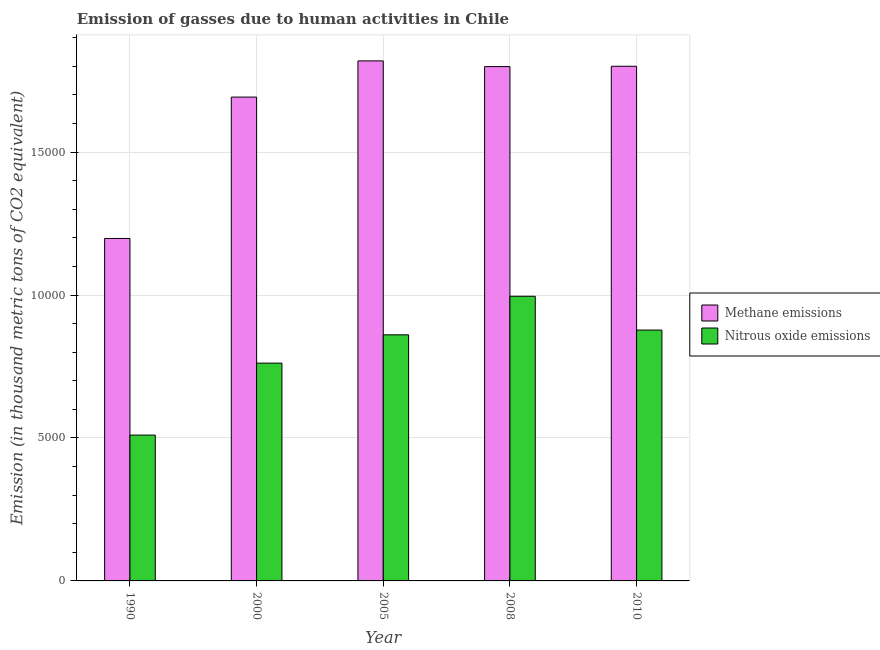How many different coloured bars are there?
Provide a short and direct response. 2. How many bars are there on the 1st tick from the right?
Your answer should be compact. 2. What is the label of the 4th group of bars from the left?
Provide a succinct answer. 2008. In how many cases, is the number of bars for a given year not equal to the number of legend labels?
Ensure brevity in your answer.  0. What is the amount of nitrous oxide emissions in 2000?
Offer a terse response. 7617.9. Across all years, what is the maximum amount of methane emissions?
Offer a terse response. 1.82e+04. Across all years, what is the minimum amount of nitrous oxide emissions?
Your answer should be very brief. 5100.7. In which year was the amount of nitrous oxide emissions maximum?
Give a very brief answer. 2008. In which year was the amount of methane emissions minimum?
Give a very brief answer. 1990. What is the total amount of nitrous oxide emissions in the graph?
Ensure brevity in your answer.  4.01e+04. What is the difference between the amount of methane emissions in 1990 and that in 2010?
Your answer should be very brief. -6023.2. What is the difference between the amount of methane emissions in 1990 and the amount of nitrous oxide emissions in 2000?
Provide a succinct answer. -4945.1. What is the average amount of nitrous oxide emissions per year?
Your response must be concise. 8011.34. In the year 2000, what is the difference between the amount of methane emissions and amount of nitrous oxide emissions?
Provide a short and direct response. 0. In how many years, is the amount of methane emissions greater than 14000 thousand metric tons?
Your answer should be very brief. 4. What is the ratio of the amount of methane emissions in 2005 to that in 2010?
Make the answer very short. 1.01. Is the amount of methane emissions in 2008 less than that in 2010?
Ensure brevity in your answer.  Yes. Is the difference between the amount of methane emissions in 1990 and 2010 greater than the difference between the amount of nitrous oxide emissions in 1990 and 2010?
Give a very brief answer. No. What is the difference between the highest and the second highest amount of methane emissions?
Keep it short and to the point. 188.4. What is the difference between the highest and the lowest amount of methane emissions?
Offer a terse response. 6211.6. Is the sum of the amount of methane emissions in 1990 and 2000 greater than the maximum amount of nitrous oxide emissions across all years?
Ensure brevity in your answer.  Yes. What does the 2nd bar from the left in 1990 represents?
Your answer should be compact. Nitrous oxide emissions. What does the 1st bar from the right in 2000 represents?
Make the answer very short. Nitrous oxide emissions. How many bars are there?
Give a very brief answer. 10. Are all the bars in the graph horizontal?
Your answer should be very brief. No. Are the values on the major ticks of Y-axis written in scientific E-notation?
Ensure brevity in your answer.  No. Does the graph contain grids?
Your response must be concise. Yes. Where does the legend appear in the graph?
Provide a short and direct response. Center right. How many legend labels are there?
Your response must be concise. 2. What is the title of the graph?
Provide a succinct answer. Emission of gasses due to human activities in Chile. Does "Arms exports" appear as one of the legend labels in the graph?
Give a very brief answer. No. What is the label or title of the X-axis?
Your response must be concise. Year. What is the label or title of the Y-axis?
Offer a very short reply. Emission (in thousand metric tons of CO2 equivalent). What is the Emission (in thousand metric tons of CO2 equivalent) in Methane emissions in 1990?
Give a very brief answer. 1.20e+04. What is the Emission (in thousand metric tons of CO2 equivalent) in Nitrous oxide emissions in 1990?
Provide a succinct answer. 5100.7. What is the Emission (in thousand metric tons of CO2 equivalent) in Methane emissions in 2000?
Your answer should be compact. 1.69e+04. What is the Emission (in thousand metric tons of CO2 equivalent) of Nitrous oxide emissions in 2000?
Offer a terse response. 7617.9. What is the Emission (in thousand metric tons of CO2 equivalent) in Methane emissions in 2005?
Provide a short and direct response. 1.82e+04. What is the Emission (in thousand metric tons of CO2 equivalent) in Nitrous oxide emissions in 2005?
Your answer should be very brief. 8607.6. What is the Emission (in thousand metric tons of CO2 equivalent) in Methane emissions in 2008?
Give a very brief answer. 1.80e+04. What is the Emission (in thousand metric tons of CO2 equivalent) in Nitrous oxide emissions in 2008?
Your answer should be compact. 9956.7. What is the Emission (in thousand metric tons of CO2 equivalent) in Methane emissions in 2010?
Provide a succinct answer. 1.80e+04. What is the Emission (in thousand metric tons of CO2 equivalent) in Nitrous oxide emissions in 2010?
Offer a very short reply. 8773.8. Across all years, what is the maximum Emission (in thousand metric tons of CO2 equivalent) of Methane emissions?
Your response must be concise. 1.82e+04. Across all years, what is the maximum Emission (in thousand metric tons of CO2 equivalent) in Nitrous oxide emissions?
Give a very brief answer. 9956.7. Across all years, what is the minimum Emission (in thousand metric tons of CO2 equivalent) in Methane emissions?
Your answer should be very brief. 1.20e+04. Across all years, what is the minimum Emission (in thousand metric tons of CO2 equivalent) in Nitrous oxide emissions?
Your response must be concise. 5100.7. What is the total Emission (in thousand metric tons of CO2 equivalent) of Methane emissions in the graph?
Give a very brief answer. 8.31e+04. What is the total Emission (in thousand metric tons of CO2 equivalent) of Nitrous oxide emissions in the graph?
Offer a very short reply. 4.01e+04. What is the difference between the Emission (in thousand metric tons of CO2 equivalent) of Methane emissions in 1990 and that in 2000?
Your answer should be very brief. -4945.1. What is the difference between the Emission (in thousand metric tons of CO2 equivalent) in Nitrous oxide emissions in 1990 and that in 2000?
Keep it short and to the point. -2517.2. What is the difference between the Emission (in thousand metric tons of CO2 equivalent) in Methane emissions in 1990 and that in 2005?
Keep it short and to the point. -6211.6. What is the difference between the Emission (in thousand metric tons of CO2 equivalent) in Nitrous oxide emissions in 1990 and that in 2005?
Provide a short and direct response. -3506.9. What is the difference between the Emission (in thousand metric tons of CO2 equivalent) of Methane emissions in 1990 and that in 2008?
Your response must be concise. -6011.3. What is the difference between the Emission (in thousand metric tons of CO2 equivalent) of Nitrous oxide emissions in 1990 and that in 2008?
Offer a very short reply. -4856. What is the difference between the Emission (in thousand metric tons of CO2 equivalent) of Methane emissions in 1990 and that in 2010?
Keep it short and to the point. -6023.2. What is the difference between the Emission (in thousand metric tons of CO2 equivalent) in Nitrous oxide emissions in 1990 and that in 2010?
Offer a very short reply. -3673.1. What is the difference between the Emission (in thousand metric tons of CO2 equivalent) of Methane emissions in 2000 and that in 2005?
Offer a terse response. -1266.5. What is the difference between the Emission (in thousand metric tons of CO2 equivalent) in Nitrous oxide emissions in 2000 and that in 2005?
Provide a short and direct response. -989.7. What is the difference between the Emission (in thousand metric tons of CO2 equivalent) of Methane emissions in 2000 and that in 2008?
Provide a succinct answer. -1066.2. What is the difference between the Emission (in thousand metric tons of CO2 equivalent) in Nitrous oxide emissions in 2000 and that in 2008?
Your answer should be very brief. -2338.8. What is the difference between the Emission (in thousand metric tons of CO2 equivalent) in Methane emissions in 2000 and that in 2010?
Make the answer very short. -1078.1. What is the difference between the Emission (in thousand metric tons of CO2 equivalent) of Nitrous oxide emissions in 2000 and that in 2010?
Your response must be concise. -1155.9. What is the difference between the Emission (in thousand metric tons of CO2 equivalent) in Methane emissions in 2005 and that in 2008?
Your answer should be compact. 200.3. What is the difference between the Emission (in thousand metric tons of CO2 equivalent) in Nitrous oxide emissions in 2005 and that in 2008?
Provide a succinct answer. -1349.1. What is the difference between the Emission (in thousand metric tons of CO2 equivalent) in Methane emissions in 2005 and that in 2010?
Offer a very short reply. 188.4. What is the difference between the Emission (in thousand metric tons of CO2 equivalent) of Nitrous oxide emissions in 2005 and that in 2010?
Offer a terse response. -166.2. What is the difference between the Emission (in thousand metric tons of CO2 equivalent) of Nitrous oxide emissions in 2008 and that in 2010?
Give a very brief answer. 1182.9. What is the difference between the Emission (in thousand metric tons of CO2 equivalent) in Methane emissions in 1990 and the Emission (in thousand metric tons of CO2 equivalent) in Nitrous oxide emissions in 2000?
Give a very brief answer. 4360.2. What is the difference between the Emission (in thousand metric tons of CO2 equivalent) in Methane emissions in 1990 and the Emission (in thousand metric tons of CO2 equivalent) in Nitrous oxide emissions in 2005?
Ensure brevity in your answer.  3370.5. What is the difference between the Emission (in thousand metric tons of CO2 equivalent) in Methane emissions in 1990 and the Emission (in thousand metric tons of CO2 equivalent) in Nitrous oxide emissions in 2008?
Ensure brevity in your answer.  2021.4. What is the difference between the Emission (in thousand metric tons of CO2 equivalent) in Methane emissions in 1990 and the Emission (in thousand metric tons of CO2 equivalent) in Nitrous oxide emissions in 2010?
Your response must be concise. 3204.3. What is the difference between the Emission (in thousand metric tons of CO2 equivalent) of Methane emissions in 2000 and the Emission (in thousand metric tons of CO2 equivalent) of Nitrous oxide emissions in 2005?
Your answer should be compact. 8315.6. What is the difference between the Emission (in thousand metric tons of CO2 equivalent) of Methane emissions in 2000 and the Emission (in thousand metric tons of CO2 equivalent) of Nitrous oxide emissions in 2008?
Ensure brevity in your answer.  6966.5. What is the difference between the Emission (in thousand metric tons of CO2 equivalent) in Methane emissions in 2000 and the Emission (in thousand metric tons of CO2 equivalent) in Nitrous oxide emissions in 2010?
Your answer should be compact. 8149.4. What is the difference between the Emission (in thousand metric tons of CO2 equivalent) in Methane emissions in 2005 and the Emission (in thousand metric tons of CO2 equivalent) in Nitrous oxide emissions in 2008?
Offer a terse response. 8233. What is the difference between the Emission (in thousand metric tons of CO2 equivalent) in Methane emissions in 2005 and the Emission (in thousand metric tons of CO2 equivalent) in Nitrous oxide emissions in 2010?
Ensure brevity in your answer.  9415.9. What is the difference between the Emission (in thousand metric tons of CO2 equivalent) of Methane emissions in 2008 and the Emission (in thousand metric tons of CO2 equivalent) of Nitrous oxide emissions in 2010?
Provide a succinct answer. 9215.6. What is the average Emission (in thousand metric tons of CO2 equivalent) of Methane emissions per year?
Provide a short and direct response. 1.66e+04. What is the average Emission (in thousand metric tons of CO2 equivalent) in Nitrous oxide emissions per year?
Give a very brief answer. 8011.34. In the year 1990, what is the difference between the Emission (in thousand metric tons of CO2 equivalent) in Methane emissions and Emission (in thousand metric tons of CO2 equivalent) in Nitrous oxide emissions?
Your response must be concise. 6877.4. In the year 2000, what is the difference between the Emission (in thousand metric tons of CO2 equivalent) of Methane emissions and Emission (in thousand metric tons of CO2 equivalent) of Nitrous oxide emissions?
Offer a very short reply. 9305.3. In the year 2005, what is the difference between the Emission (in thousand metric tons of CO2 equivalent) of Methane emissions and Emission (in thousand metric tons of CO2 equivalent) of Nitrous oxide emissions?
Provide a short and direct response. 9582.1. In the year 2008, what is the difference between the Emission (in thousand metric tons of CO2 equivalent) of Methane emissions and Emission (in thousand metric tons of CO2 equivalent) of Nitrous oxide emissions?
Your response must be concise. 8032.7. In the year 2010, what is the difference between the Emission (in thousand metric tons of CO2 equivalent) of Methane emissions and Emission (in thousand metric tons of CO2 equivalent) of Nitrous oxide emissions?
Ensure brevity in your answer.  9227.5. What is the ratio of the Emission (in thousand metric tons of CO2 equivalent) in Methane emissions in 1990 to that in 2000?
Keep it short and to the point. 0.71. What is the ratio of the Emission (in thousand metric tons of CO2 equivalent) in Nitrous oxide emissions in 1990 to that in 2000?
Give a very brief answer. 0.67. What is the ratio of the Emission (in thousand metric tons of CO2 equivalent) of Methane emissions in 1990 to that in 2005?
Your answer should be very brief. 0.66. What is the ratio of the Emission (in thousand metric tons of CO2 equivalent) in Nitrous oxide emissions in 1990 to that in 2005?
Offer a terse response. 0.59. What is the ratio of the Emission (in thousand metric tons of CO2 equivalent) in Methane emissions in 1990 to that in 2008?
Provide a short and direct response. 0.67. What is the ratio of the Emission (in thousand metric tons of CO2 equivalent) of Nitrous oxide emissions in 1990 to that in 2008?
Ensure brevity in your answer.  0.51. What is the ratio of the Emission (in thousand metric tons of CO2 equivalent) in Methane emissions in 1990 to that in 2010?
Your response must be concise. 0.67. What is the ratio of the Emission (in thousand metric tons of CO2 equivalent) of Nitrous oxide emissions in 1990 to that in 2010?
Your answer should be very brief. 0.58. What is the ratio of the Emission (in thousand metric tons of CO2 equivalent) in Methane emissions in 2000 to that in 2005?
Make the answer very short. 0.93. What is the ratio of the Emission (in thousand metric tons of CO2 equivalent) in Nitrous oxide emissions in 2000 to that in 2005?
Ensure brevity in your answer.  0.89. What is the ratio of the Emission (in thousand metric tons of CO2 equivalent) in Methane emissions in 2000 to that in 2008?
Ensure brevity in your answer.  0.94. What is the ratio of the Emission (in thousand metric tons of CO2 equivalent) of Nitrous oxide emissions in 2000 to that in 2008?
Provide a succinct answer. 0.77. What is the ratio of the Emission (in thousand metric tons of CO2 equivalent) in Methane emissions in 2000 to that in 2010?
Make the answer very short. 0.94. What is the ratio of the Emission (in thousand metric tons of CO2 equivalent) of Nitrous oxide emissions in 2000 to that in 2010?
Your response must be concise. 0.87. What is the ratio of the Emission (in thousand metric tons of CO2 equivalent) of Methane emissions in 2005 to that in 2008?
Give a very brief answer. 1.01. What is the ratio of the Emission (in thousand metric tons of CO2 equivalent) in Nitrous oxide emissions in 2005 to that in 2008?
Keep it short and to the point. 0.86. What is the ratio of the Emission (in thousand metric tons of CO2 equivalent) in Methane emissions in 2005 to that in 2010?
Give a very brief answer. 1.01. What is the ratio of the Emission (in thousand metric tons of CO2 equivalent) of Nitrous oxide emissions in 2005 to that in 2010?
Your response must be concise. 0.98. What is the ratio of the Emission (in thousand metric tons of CO2 equivalent) of Methane emissions in 2008 to that in 2010?
Your answer should be compact. 1. What is the ratio of the Emission (in thousand metric tons of CO2 equivalent) of Nitrous oxide emissions in 2008 to that in 2010?
Offer a terse response. 1.13. What is the difference between the highest and the second highest Emission (in thousand metric tons of CO2 equivalent) in Methane emissions?
Give a very brief answer. 188.4. What is the difference between the highest and the second highest Emission (in thousand metric tons of CO2 equivalent) in Nitrous oxide emissions?
Your response must be concise. 1182.9. What is the difference between the highest and the lowest Emission (in thousand metric tons of CO2 equivalent) of Methane emissions?
Keep it short and to the point. 6211.6. What is the difference between the highest and the lowest Emission (in thousand metric tons of CO2 equivalent) in Nitrous oxide emissions?
Offer a very short reply. 4856. 